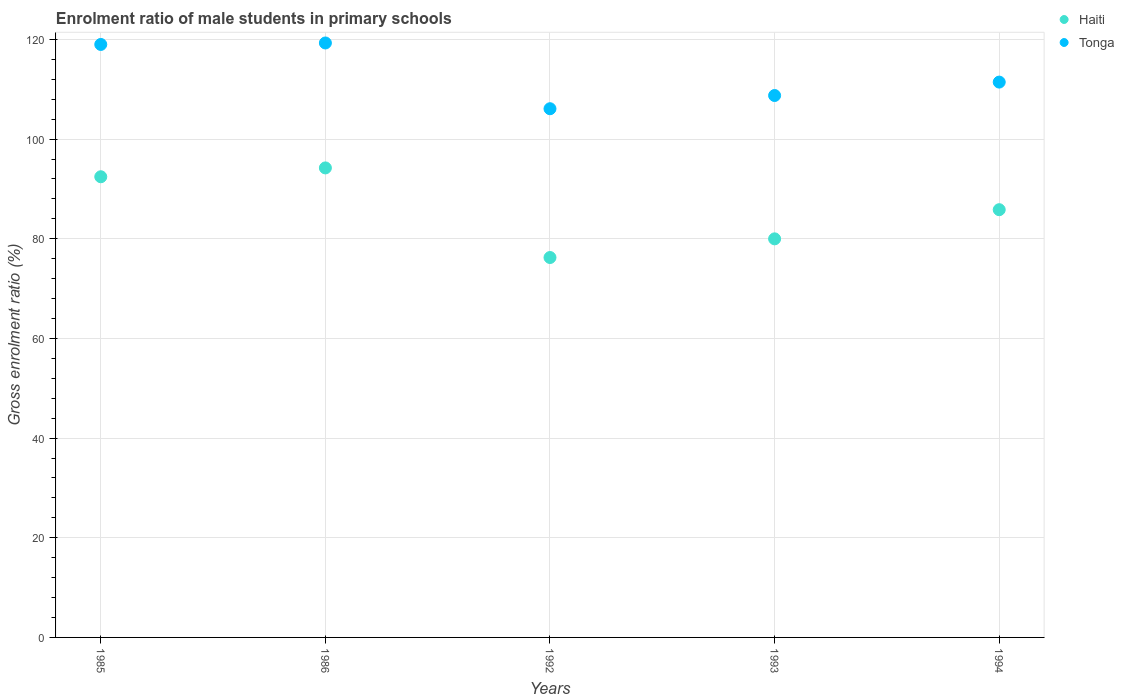What is the enrolment ratio of male students in primary schools in Haiti in 1994?
Keep it short and to the point. 85.84. Across all years, what is the maximum enrolment ratio of male students in primary schools in Haiti?
Offer a terse response. 94.22. Across all years, what is the minimum enrolment ratio of male students in primary schools in Tonga?
Offer a terse response. 106.1. What is the total enrolment ratio of male students in primary schools in Haiti in the graph?
Make the answer very short. 428.73. What is the difference between the enrolment ratio of male students in primary schools in Tonga in 1993 and that in 1994?
Your answer should be very brief. -2.69. What is the difference between the enrolment ratio of male students in primary schools in Haiti in 1985 and the enrolment ratio of male students in primary schools in Tonga in 1994?
Keep it short and to the point. -19. What is the average enrolment ratio of male students in primary schools in Tonga per year?
Your answer should be very brief. 112.92. In the year 1985, what is the difference between the enrolment ratio of male students in primary schools in Tonga and enrolment ratio of male students in primary schools in Haiti?
Provide a succinct answer. 26.55. What is the ratio of the enrolment ratio of male students in primary schools in Tonga in 1985 to that in 1992?
Offer a terse response. 1.12. Is the difference between the enrolment ratio of male students in primary schools in Tonga in 1985 and 1992 greater than the difference between the enrolment ratio of male students in primary schools in Haiti in 1985 and 1992?
Give a very brief answer. No. What is the difference between the highest and the second highest enrolment ratio of male students in primary schools in Haiti?
Offer a terse response. 1.77. What is the difference between the highest and the lowest enrolment ratio of male students in primary schools in Tonga?
Your answer should be very brief. 13.19. Does the enrolment ratio of male students in primary schools in Tonga monotonically increase over the years?
Provide a succinct answer. No. Is the enrolment ratio of male students in primary schools in Tonga strictly greater than the enrolment ratio of male students in primary schools in Haiti over the years?
Make the answer very short. Yes. Are the values on the major ticks of Y-axis written in scientific E-notation?
Ensure brevity in your answer.  No. Where does the legend appear in the graph?
Your answer should be compact. Top right. How many legend labels are there?
Ensure brevity in your answer.  2. What is the title of the graph?
Give a very brief answer. Enrolment ratio of male students in primary schools. Does "New Zealand" appear as one of the legend labels in the graph?
Offer a very short reply. No. What is the label or title of the X-axis?
Make the answer very short. Years. What is the label or title of the Y-axis?
Your answer should be compact. Gross enrolment ratio (%). What is the Gross enrolment ratio (%) of Haiti in 1985?
Your response must be concise. 92.45. What is the Gross enrolment ratio (%) of Tonga in 1985?
Your answer should be compact. 119. What is the Gross enrolment ratio (%) of Haiti in 1986?
Keep it short and to the point. 94.22. What is the Gross enrolment ratio (%) in Tonga in 1986?
Offer a terse response. 119.29. What is the Gross enrolment ratio (%) of Haiti in 1992?
Your answer should be very brief. 76.24. What is the Gross enrolment ratio (%) in Tonga in 1992?
Ensure brevity in your answer.  106.1. What is the Gross enrolment ratio (%) of Haiti in 1993?
Ensure brevity in your answer.  79.99. What is the Gross enrolment ratio (%) of Tonga in 1993?
Provide a short and direct response. 108.75. What is the Gross enrolment ratio (%) of Haiti in 1994?
Ensure brevity in your answer.  85.84. What is the Gross enrolment ratio (%) in Tonga in 1994?
Make the answer very short. 111.44. Across all years, what is the maximum Gross enrolment ratio (%) in Haiti?
Provide a succinct answer. 94.22. Across all years, what is the maximum Gross enrolment ratio (%) of Tonga?
Ensure brevity in your answer.  119.29. Across all years, what is the minimum Gross enrolment ratio (%) of Haiti?
Your response must be concise. 76.24. Across all years, what is the minimum Gross enrolment ratio (%) in Tonga?
Your response must be concise. 106.1. What is the total Gross enrolment ratio (%) of Haiti in the graph?
Keep it short and to the point. 428.73. What is the total Gross enrolment ratio (%) of Tonga in the graph?
Ensure brevity in your answer.  564.59. What is the difference between the Gross enrolment ratio (%) of Haiti in 1985 and that in 1986?
Your response must be concise. -1.77. What is the difference between the Gross enrolment ratio (%) of Tonga in 1985 and that in 1986?
Provide a succinct answer. -0.3. What is the difference between the Gross enrolment ratio (%) in Haiti in 1985 and that in 1992?
Your response must be concise. 16.21. What is the difference between the Gross enrolment ratio (%) in Tonga in 1985 and that in 1992?
Your answer should be compact. 12.9. What is the difference between the Gross enrolment ratio (%) in Haiti in 1985 and that in 1993?
Give a very brief answer. 12.46. What is the difference between the Gross enrolment ratio (%) of Tonga in 1985 and that in 1993?
Offer a very short reply. 10.25. What is the difference between the Gross enrolment ratio (%) of Haiti in 1985 and that in 1994?
Your answer should be very brief. 6.61. What is the difference between the Gross enrolment ratio (%) in Tonga in 1985 and that in 1994?
Provide a short and direct response. 7.55. What is the difference between the Gross enrolment ratio (%) of Haiti in 1986 and that in 1992?
Offer a very short reply. 17.98. What is the difference between the Gross enrolment ratio (%) in Tonga in 1986 and that in 1992?
Provide a short and direct response. 13.19. What is the difference between the Gross enrolment ratio (%) of Haiti in 1986 and that in 1993?
Make the answer very short. 14.23. What is the difference between the Gross enrolment ratio (%) in Tonga in 1986 and that in 1993?
Offer a terse response. 10.54. What is the difference between the Gross enrolment ratio (%) in Haiti in 1986 and that in 1994?
Your response must be concise. 8.38. What is the difference between the Gross enrolment ratio (%) of Tonga in 1986 and that in 1994?
Ensure brevity in your answer.  7.85. What is the difference between the Gross enrolment ratio (%) in Haiti in 1992 and that in 1993?
Your answer should be very brief. -3.75. What is the difference between the Gross enrolment ratio (%) in Tonga in 1992 and that in 1993?
Your answer should be very brief. -2.65. What is the difference between the Gross enrolment ratio (%) of Haiti in 1992 and that in 1994?
Provide a short and direct response. -9.6. What is the difference between the Gross enrolment ratio (%) in Tonga in 1992 and that in 1994?
Offer a terse response. -5.34. What is the difference between the Gross enrolment ratio (%) of Haiti in 1993 and that in 1994?
Your answer should be very brief. -5.85. What is the difference between the Gross enrolment ratio (%) in Tonga in 1993 and that in 1994?
Your answer should be very brief. -2.69. What is the difference between the Gross enrolment ratio (%) of Haiti in 1985 and the Gross enrolment ratio (%) of Tonga in 1986?
Give a very brief answer. -26.85. What is the difference between the Gross enrolment ratio (%) in Haiti in 1985 and the Gross enrolment ratio (%) in Tonga in 1992?
Ensure brevity in your answer.  -13.65. What is the difference between the Gross enrolment ratio (%) in Haiti in 1985 and the Gross enrolment ratio (%) in Tonga in 1993?
Make the answer very short. -16.3. What is the difference between the Gross enrolment ratio (%) in Haiti in 1985 and the Gross enrolment ratio (%) in Tonga in 1994?
Give a very brief answer. -19. What is the difference between the Gross enrolment ratio (%) of Haiti in 1986 and the Gross enrolment ratio (%) of Tonga in 1992?
Offer a terse response. -11.88. What is the difference between the Gross enrolment ratio (%) of Haiti in 1986 and the Gross enrolment ratio (%) of Tonga in 1993?
Your response must be concise. -14.53. What is the difference between the Gross enrolment ratio (%) in Haiti in 1986 and the Gross enrolment ratio (%) in Tonga in 1994?
Provide a short and direct response. -17.22. What is the difference between the Gross enrolment ratio (%) of Haiti in 1992 and the Gross enrolment ratio (%) of Tonga in 1993?
Provide a short and direct response. -32.51. What is the difference between the Gross enrolment ratio (%) in Haiti in 1992 and the Gross enrolment ratio (%) in Tonga in 1994?
Provide a succinct answer. -35.2. What is the difference between the Gross enrolment ratio (%) of Haiti in 1993 and the Gross enrolment ratio (%) of Tonga in 1994?
Make the answer very short. -31.46. What is the average Gross enrolment ratio (%) in Haiti per year?
Give a very brief answer. 85.75. What is the average Gross enrolment ratio (%) of Tonga per year?
Your response must be concise. 112.92. In the year 1985, what is the difference between the Gross enrolment ratio (%) in Haiti and Gross enrolment ratio (%) in Tonga?
Your answer should be very brief. -26.55. In the year 1986, what is the difference between the Gross enrolment ratio (%) in Haiti and Gross enrolment ratio (%) in Tonga?
Provide a short and direct response. -25.07. In the year 1992, what is the difference between the Gross enrolment ratio (%) in Haiti and Gross enrolment ratio (%) in Tonga?
Provide a short and direct response. -29.86. In the year 1993, what is the difference between the Gross enrolment ratio (%) of Haiti and Gross enrolment ratio (%) of Tonga?
Your answer should be compact. -28.76. In the year 1994, what is the difference between the Gross enrolment ratio (%) of Haiti and Gross enrolment ratio (%) of Tonga?
Give a very brief answer. -25.61. What is the ratio of the Gross enrolment ratio (%) in Haiti in 1985 to that in 1986?
Your answer should be compact. 0.98. What is the ratio of the Gross enrolment ratio (%) of Haiti in 1985 to that in 1992?
Your answer should be compact. 1.21. What is the ratio of the Gross enrolment ratio (%) of Tonga in 1985 to that in 1992?
Offer a terse response. 1.12. What is the ratio of the Gross enrolment ratio (%) of Haiti in 1985 to that in 1993?
Offer a terse response. 1.16. What is the ratio of the Gross enrolment ratio (%) of Tonga in 1985 to that in 1993?
Provide a succinct answer. 1.09. What is the ratio of the Gross enrolment ratio (%) of Haiti in 1985 to that in 1994?
Your response must be concise. 1.08. What is the ratio of the Gross enrolment ratio (%) in Tonga in 1985 to that in 1994?
Provide a succinct answer. 1.07. What is the ratio of the Gross enrolment ratio (%) of Haiti in 1986 to that in 1992?
Keep it short and to the point. 1.24. What is the ratio of the Gross enrolment ratio (%) in Tonga in 1986 to that in 1992?
Give a very brief answer. 1.12. What is the ratio of the Gross enrolment ratio (%) in Haiti in 1986 to that in 1993?
Your answer should be compact. 1.18. What is the ratio of the Gross enrolment ratio (%) in Tonga in 1986 to that in 1993?
Offer a very short reply. 1.1. What is the ratio of the Gross enrolment ratio (%) of Haiti in 1986 to that in 1994?
Your response must be concise. 1.1. What is the ratio of the Gross enrolment ratio (%) of Tonga in 1986 to that in 1994?
Your answer should be very brief. 1.07. What is the ratio of the Gross enrolment ratio (%) in Haiti in 1992 to that in 1993?
Ensure brevity in your answer.  0.95. What is the ratio of the Gross enrolment ratio (%) in Tonga in 1992 to that in 1993?
Keep it short and to the point. 0.98. What is the ratio of the Gross enrolment ratio (%) in Haiti in 1992 to that in 1994?
Give a very brief answer. 0.89. What is the ratio of the Gross enrolment ratio (%) in Haiti in 1993 to that in 1994?
Your answer should be compact. 0.93. What is the ratio of the Gross enrolment ratio (%) in Tonga in 1993 to that in 1994?
Provide a short and direct response. 0.98. What is the difference between the highest and the second highest Gross enrolment ratio (%) of Haiti?
Your answer should be compact. 1.77. What is the difference between the highest and the second highest Gross enrolment ratio (%) of Tonga?
Offer a very short reply. 0.3. What is the difference between the highest and the lowest Gross enrolment ratio (%) in Haiti?
Your answer should be compact. 17.98. What is the difference between the highest and the lowest Gross enrolment ratio (%) in Tonga?
Make the answer very short. 13.19. 